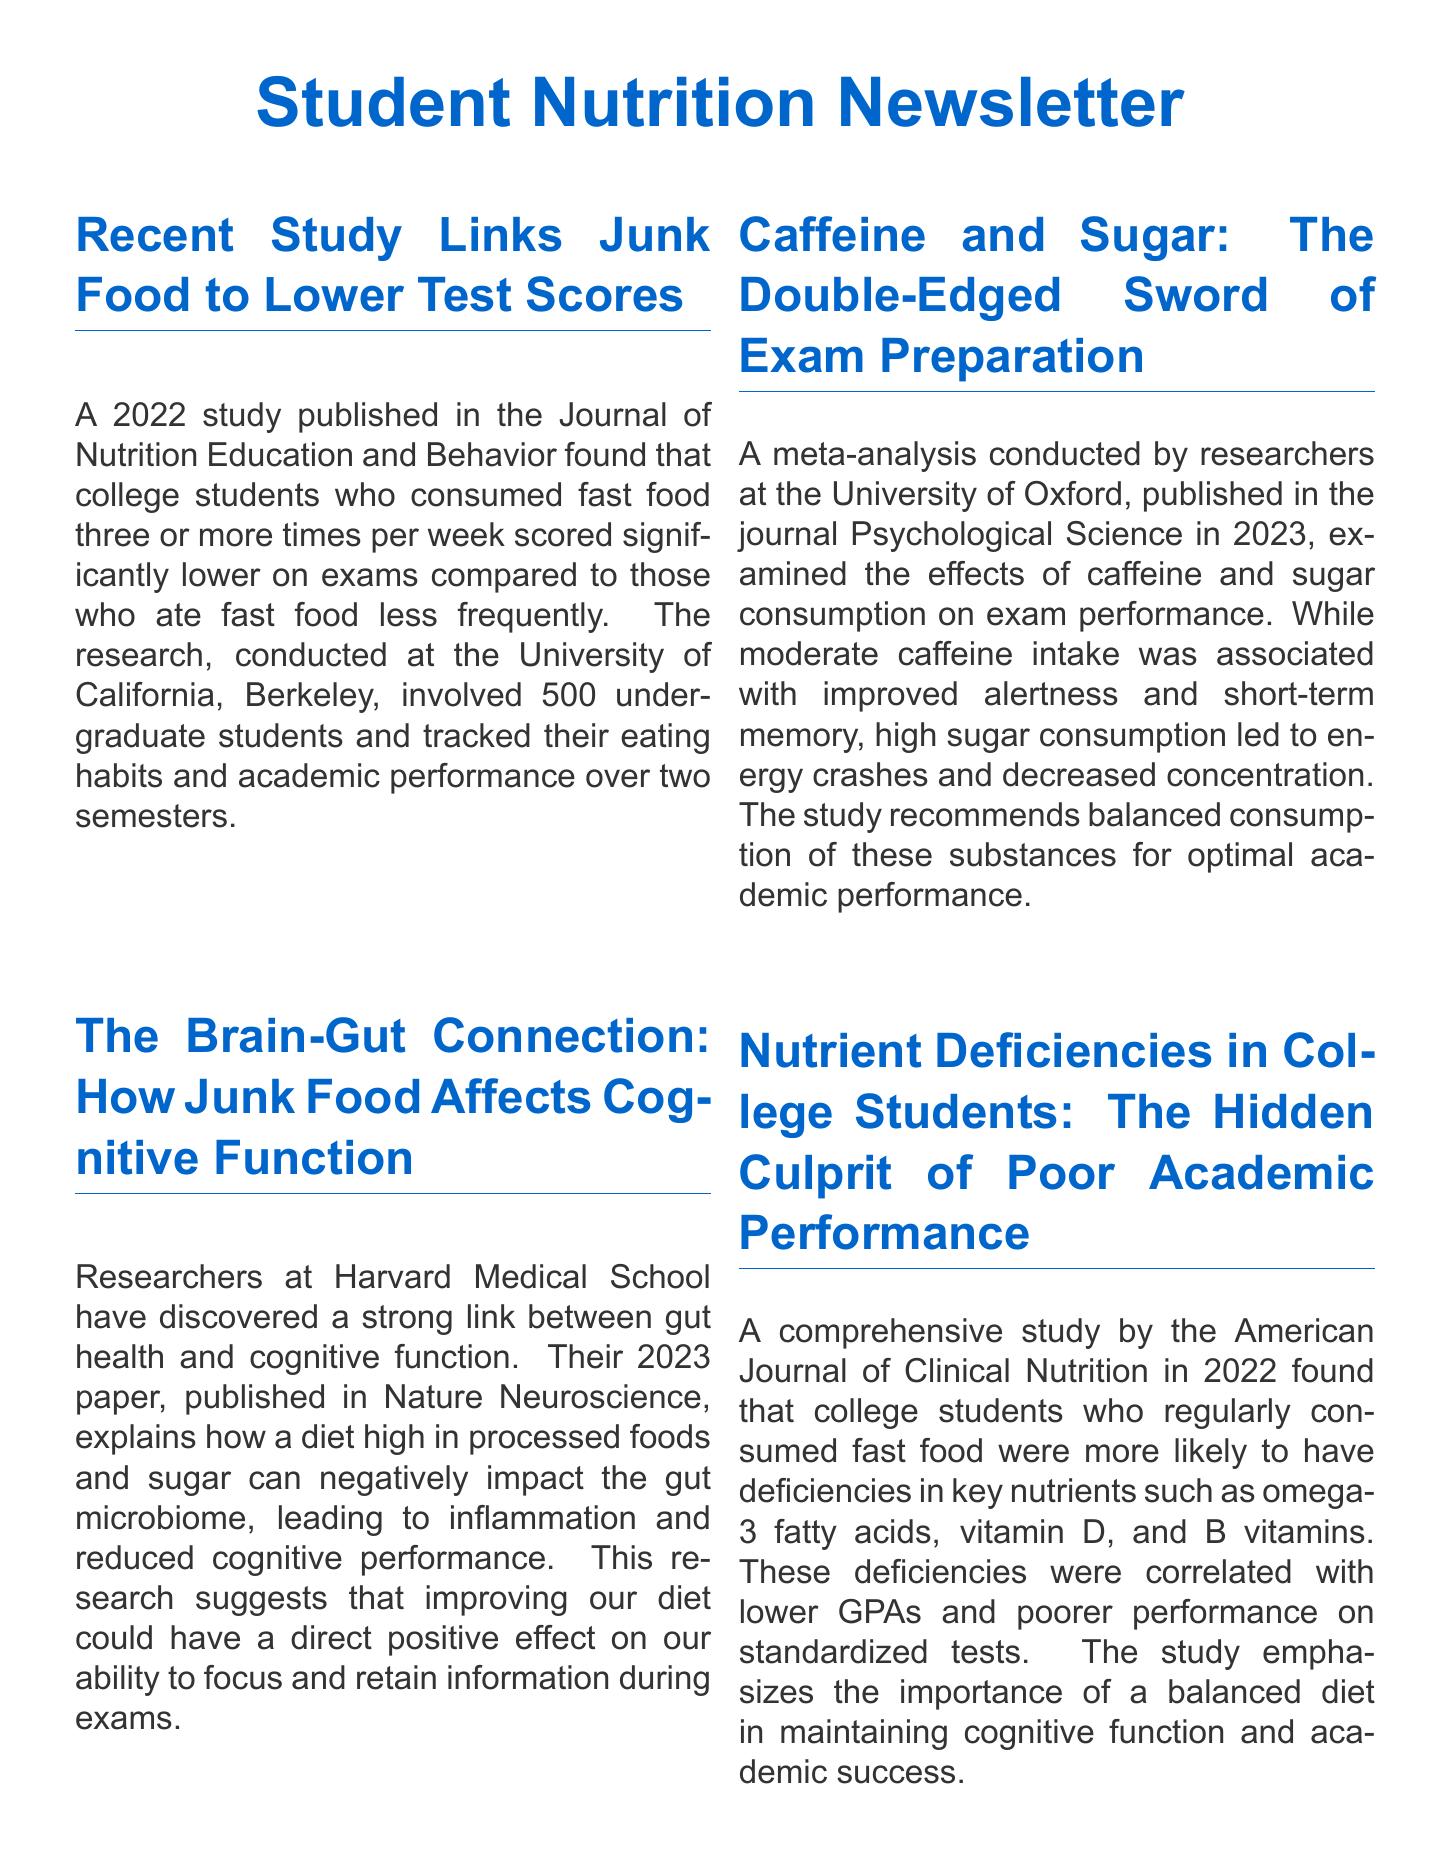What year was the study published that links junk food to lower test scores? The document states that the study was published in 2022.
Answer: 2022 What university conducted the study on caffeine and sugar consumption? The document mentions that the University of Oxford conducted the meta-analysis.
Answer: University of Oxford How many undergraduate students were involved in the study linking junk food consumption to academic performance? The study included 500 undergraduate students.
Answer: 500 What nutrient deficiencies were correlated with lower GPAs in the 2022 study? The document specifies that deficiencies in omega-3 fatty acids, vitamin D, and B vitamins were correlated with lower GPAs.
Answer: Omega-3 fatty acids, vitamin D, and B vitamins What is the date and time of the Healthy Study Snacks Workshop? The workshop is scheduled for next Thursday at 5 PM.
Answer: Next Thursday, 5 PM How long before bedtime should students avoid eating for better recall? The research suggests students should avoid eating for at least 3 hours before bedtime.
Answer: 3 hours What is the recommended consumption of caffeine and sugar for optimal academic performance? The study recommends balanced consumption of caffeine and sugar.
Answer: Balanced consumption Which publication features the research on the brain-gut connection? The document notes that the research is published in Nature Neuroscience.
Answer: Nature Neuroscience 